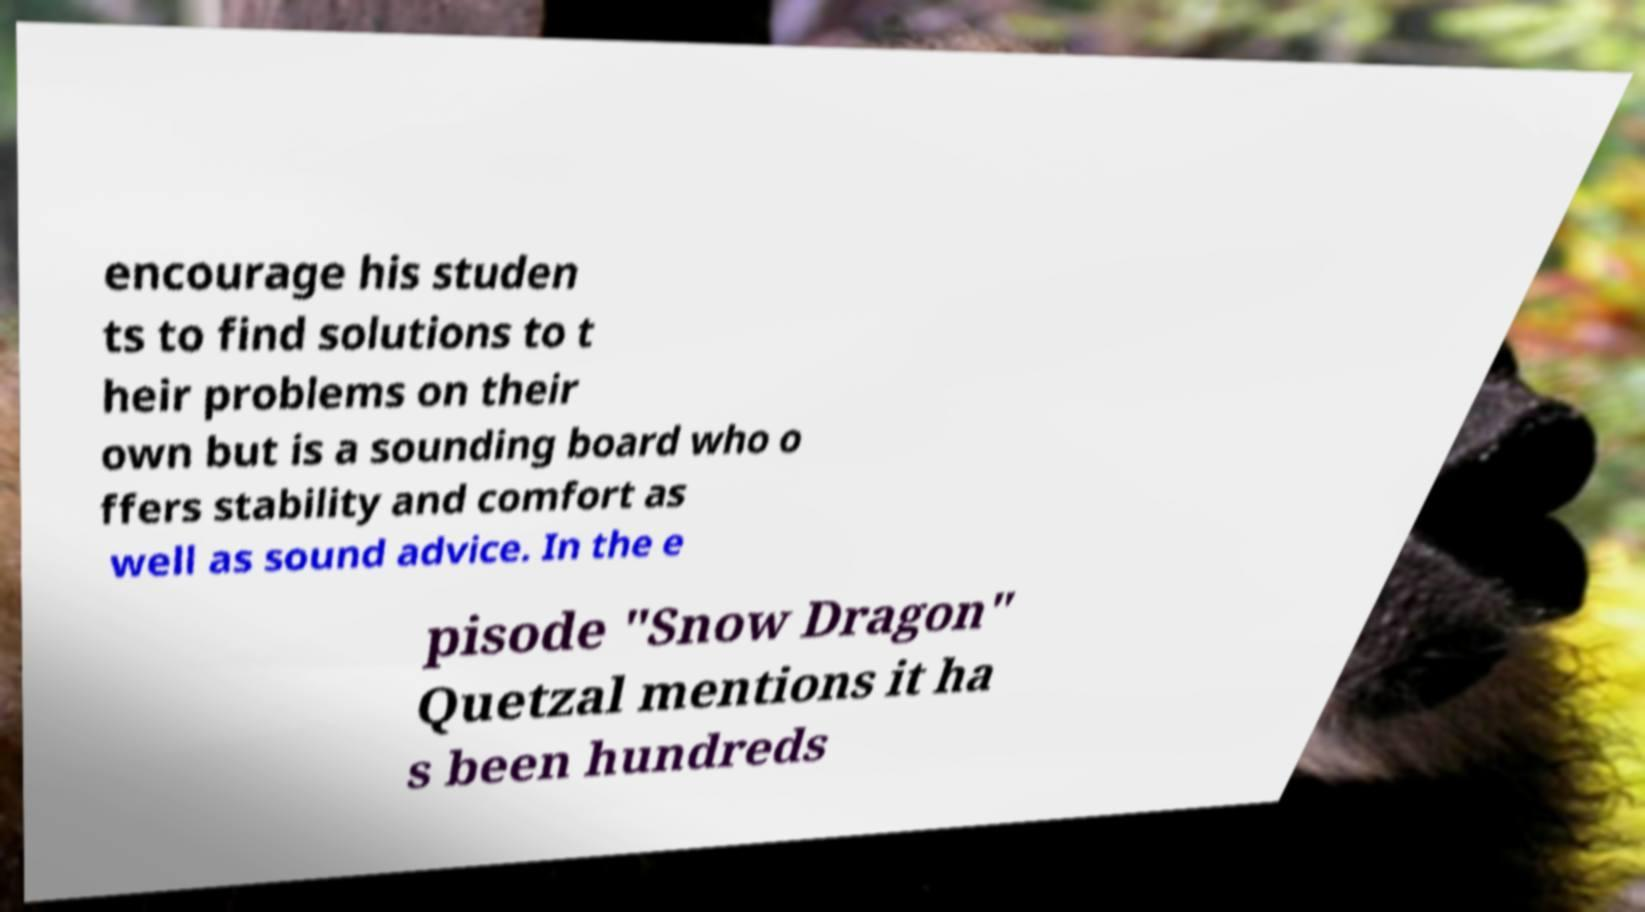For documentation purposes, I need the text within this image transcribed. Could you provide that? encourage his studen ts to find solutions to t heir problems on their own but is a sounding board who o ffers stability and comfort as well as sound advice. In the e pisode "Snow Dragon" Quetzal mentions it ha s been hundreds 